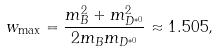<formula> <loc_0><loc_0><loc_500><loc_500>w _ { \max } = \frac { m _ { B } ^ { 2 } + m _ { D ^ { * 0 } } ^ { 2 } } { 2 m _ { B } m _ { D ^ { * 0 } } } \approx 1 . 5 0 5 ,</formula> 